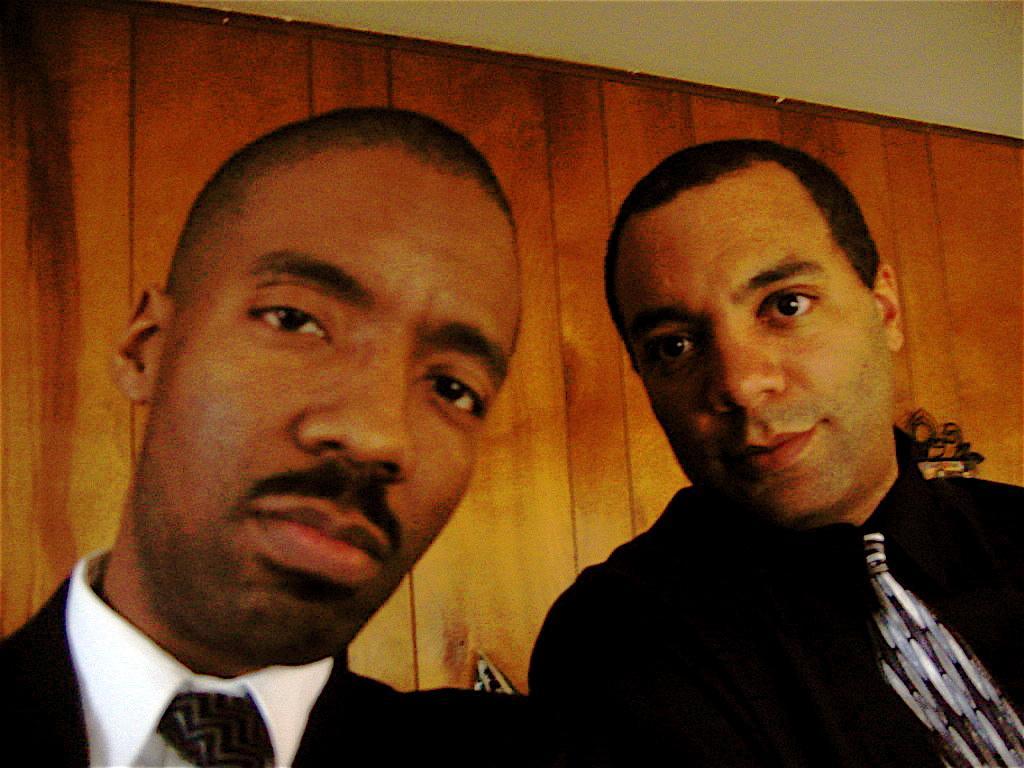Can you describe this image briefly? In this image we can see two persons, behind them there is a wooden wall, also we can see the roof. 